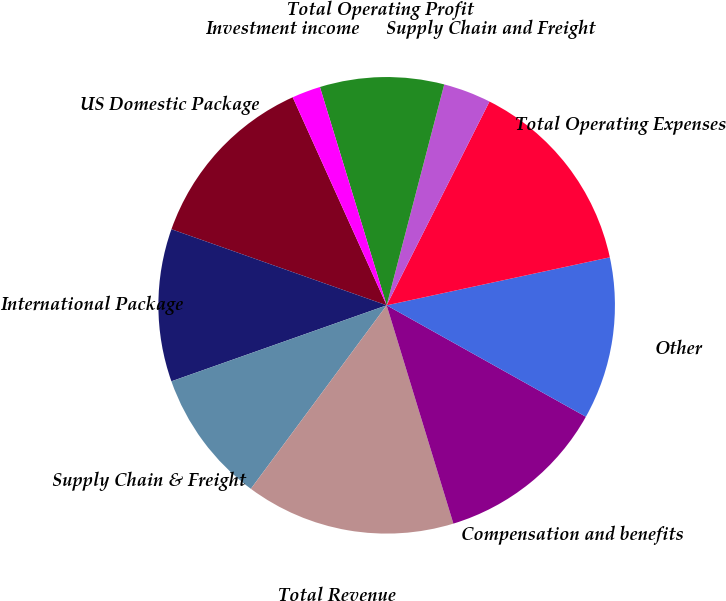<chart> <loc_0><loc_0><loc_500><loc_500><pie_chart><fcel>US Domestic Package<fcel>International Package<fcel>Supply Chain & Freight<fcel>Total Revenue<fcel>Compensation and benefits<fcel>Other<fcel>Total Operating Expenses<fcel>Supply Chain and Freight<fcel>Total Operating Profit<fcel>Investment income<nl><fcel>12.84%<fcel>10.81%<fcel>9.46%<fcel>14.86%<fcel>12.16%<fcel>11.49%<fcel>14.19%<fcel>3.38%<fcel>8.78%<fcel>2.03%<nl></chart> 